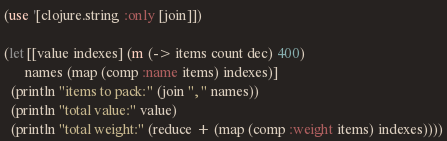<code> <loc_0><loc_0><loc_500><loc_500><_Clojure_>(use '[clojure.string :only [join]])

(let [[value indexes] (m (-> items count dec) 400)
      names (map (comp :name items) indexes)]
  (println "items to pack:" (join ", " names))
  (println "total value:" value)
  (println "total weight:" (reduce + (map (comp :weight items) indexes))))
</code> 